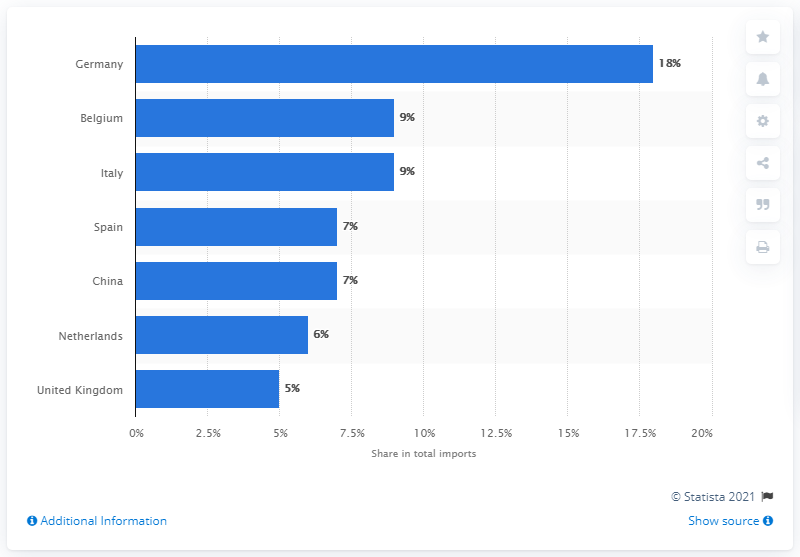Highlight a few significant elements in this photo. In 2019, Germany was the most significant import partner for France. 